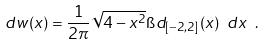<formula> <loc_0><loc_0><loc_500><loc_500>d w ( x ) = \frac { 1 } { 2 \pi } \sqrt { 4 - x ^ { 2 } } \i d _ { [ - 2 , 2 ] } ( x ) \ d x \ .</formula> 